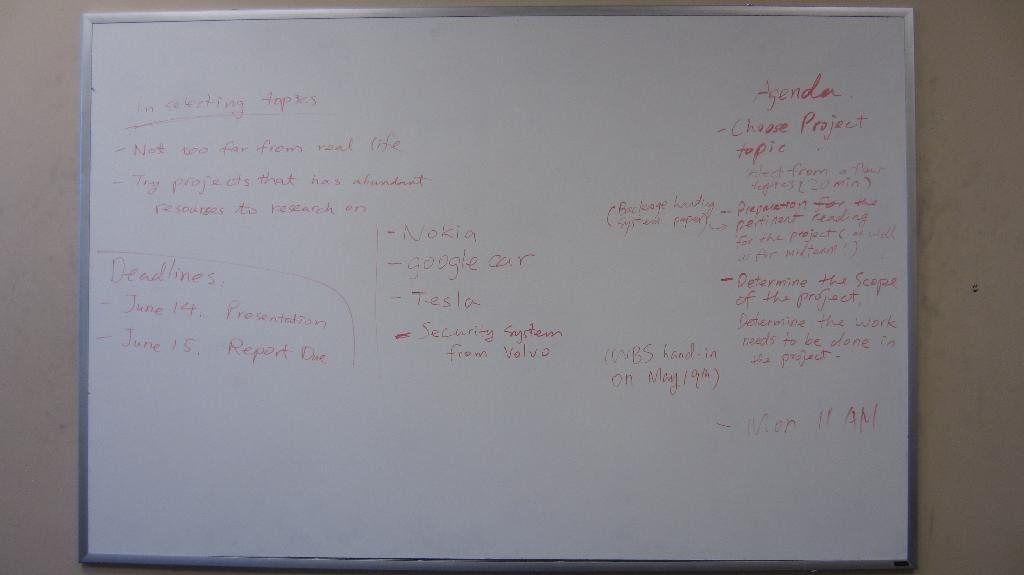<image>
Share a concise interpretation of the image provided. A white board with information on selecting a topic for a report. 